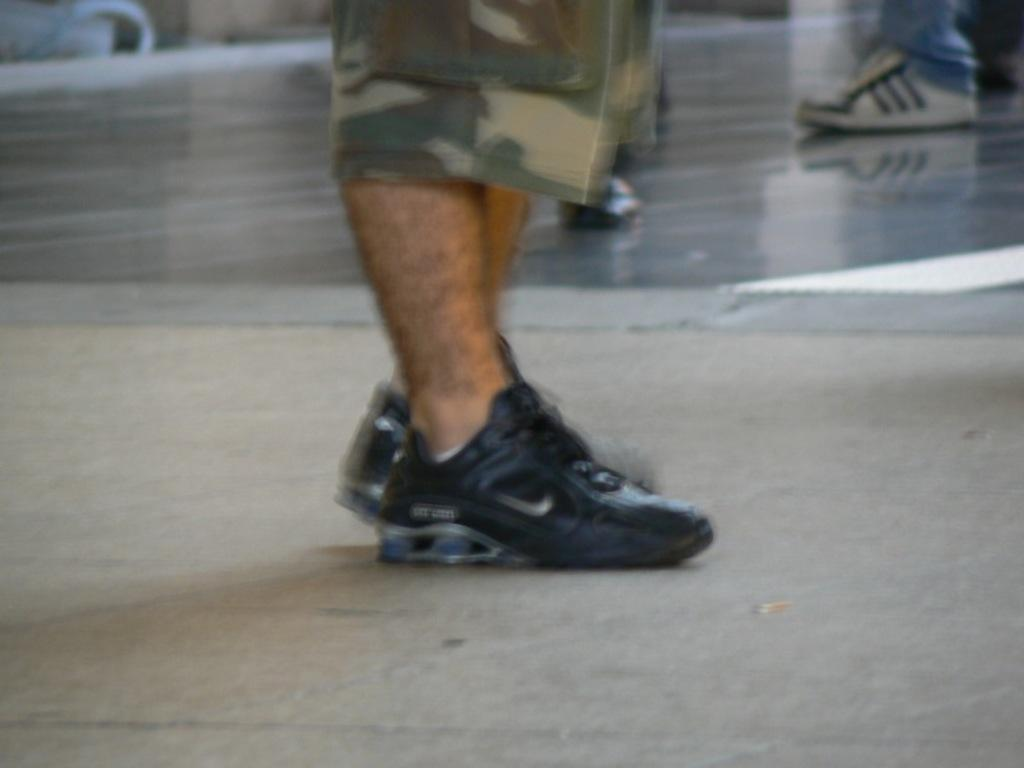What part of a person's body is visible in the image? There is a person's leg visible in the image. What is the person's leg wearing? The person's leg is wearing shoes. What surface is the person standing on? The person is standing on the floor. What type of example can be seen in the office in the image? There is no office or example present in the image; it only shows a person's leg wearing shoes and standing on the floor. 